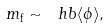<formula> <loc_0><loc_0><loc_500><loc_500>m _ { \text {f} } \sim \ h b \langle \phi \rangle ,</formula> 